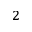Convert formula to latex. <formula><loc_0><loc_0><loc_500><loc_500>^ { 2 }</formula> 